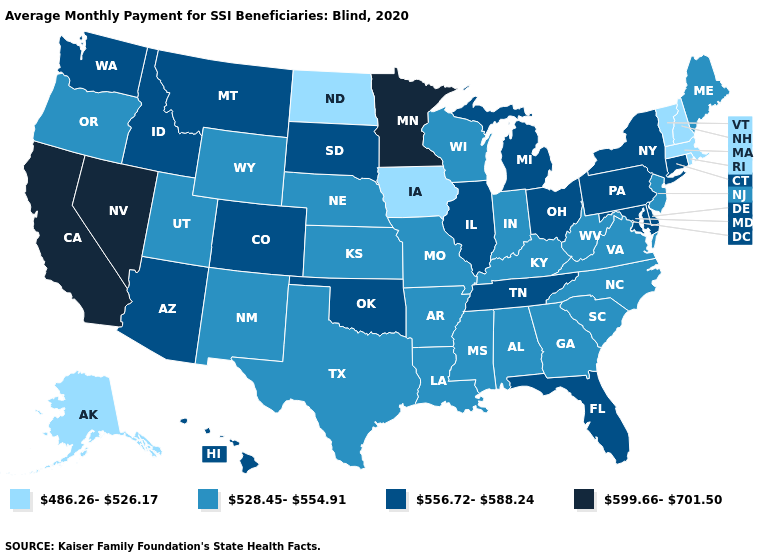Does the first symbol in the legend represent the smallest category?
Quick response, please. Yes. Name the states that have a value in the range 528.45-554.91?
Short answer required. Alabama, Arkansas, Georgia, Indiana, Kansas, Kentucky, Louisiana, Maine, Mississippi, Missouri, Nebraska, New Jersey, New Mexico, North Carolina, Oregon, South Carolina, Texas, Utah, Virginia, West Virginia, Wisconsin, Wyoming. What is the value of Illinois?
Be succinct. 556.72-588.24. Does Idaho have the lowest value in the West?
Concise answer only. No. What is the lowest value in the USA?
Answer briefly. 486.26-526.17. Name the states that have a value in the range 556.72-588.24?
Answer briefly. Arizona, Colorado, Connecticut, Delaware, Florida, Hawaii, Idaho, Illinois, Maryland, Michigan, Montana, New York, Ohio, Oklahoma, Pennsylvania, South Dakota, Tennessee, Washington. What is the value of New York?
Answer briefly. 556.72-588.24. Among the states that border Maine , which have the highest value?
Write a very short answer. New Hampshire. Name the states that have a value in the range 556.72-588.24?
Concise answer only. Arizona, Colorado, Connecticut, Delaware, Florida, Hawaii, Idaho, Illinois, Maryland, Michigan, Montana, New York, Ohio, Oklahoma, Pennsylvania, South Dakota, Tennessee, Washington. Name the states that have a value in the range 556.72-588.24?
Short answer required. Arizona, Colorado, Connecticut, Delaware, Florida, Hawaii, Idaho, Illinois, Maryland, Michigan, Montana, New York, Ohio, Oklahoma, Pennsylvania, South Dakota, Tennessee, Washington. Name the states that have a value in the range 599.66-701.50?
Quick response, please. California, Minnesota, Nevada. What is the value of Louisiana?
Concise answer only. 528.45-554.91. Which states have the lowest value in the USA?
Short answer required. Alaska, Iowa, Massachusetts, New Hampshire, North Dakota, Rhode Island, Vermont. Name the states that have a value in the range 556.72-588.24?
Concise answer only. Arizona, Colorado, Connecticut, Delaware, Florida, Hawaii, Idaho, Illinois, Maryland, Michigan, Montana, New York, Ohio, Oklahoma, Pennsylvania, South Dakota, Tennessee, Washington. What is the value of South Dakota?
Keep it brief. 556.72-588.24. 